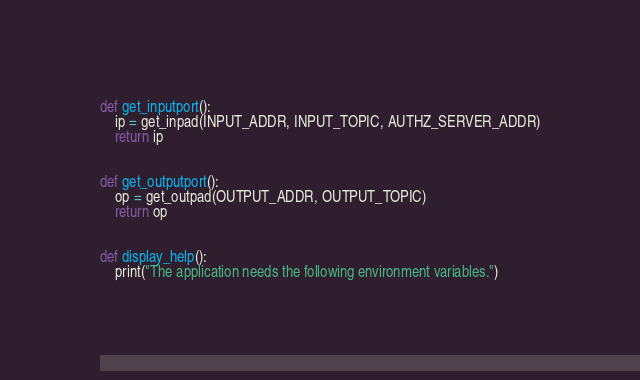<code> <loc_0><loc_0><loc_500><loc_500><_Python_>def get_inputport():
    ip = get_inpad(INPUT_ADDR, INPUT_TOPIC, AUTHZ_SERVER_ADDR)
    return ip


def get_outputport():
    op = get_outpad(OUTPUT_ADDR, OUTPUT_TOPIC)
    return op


def display_help():
    print("The application needs the following environment variables.")</code> 